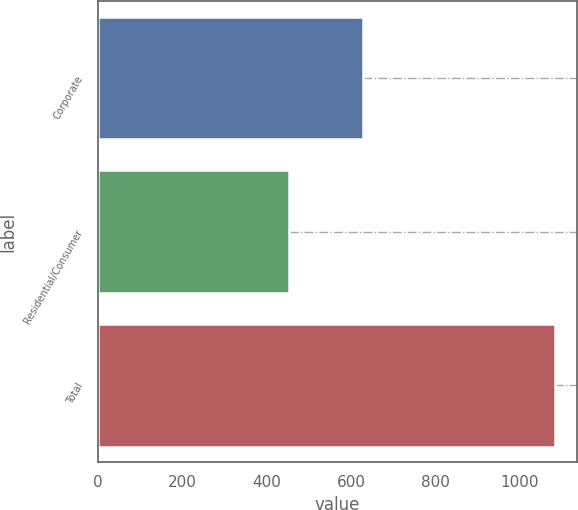Convert chart. <chart><loc_0><loc_0><loc_500><loc_500><bar_chart><fcel>Corporate<fcel>Residential/Consumer<fcel>Total<nl><fcel>629<fcel>453<fcel>1082<nl></chart> 